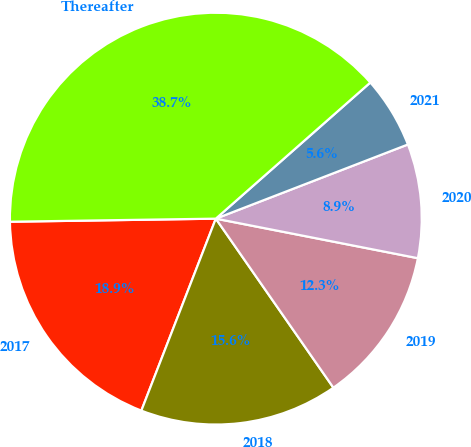<chart> <loc_0><loc_0><loc_500><loc_500><pie_chart><fcel>2017<fcel>2018<fcel>2019<fcel>2020<fcel>2021<fcel>Thereafter<nl><fcel>18.87%<fcel>15.56%<fcel>12.25%<fcel>8.94%<fcel>5.63%<fcel>38.74%<nl></chart> 